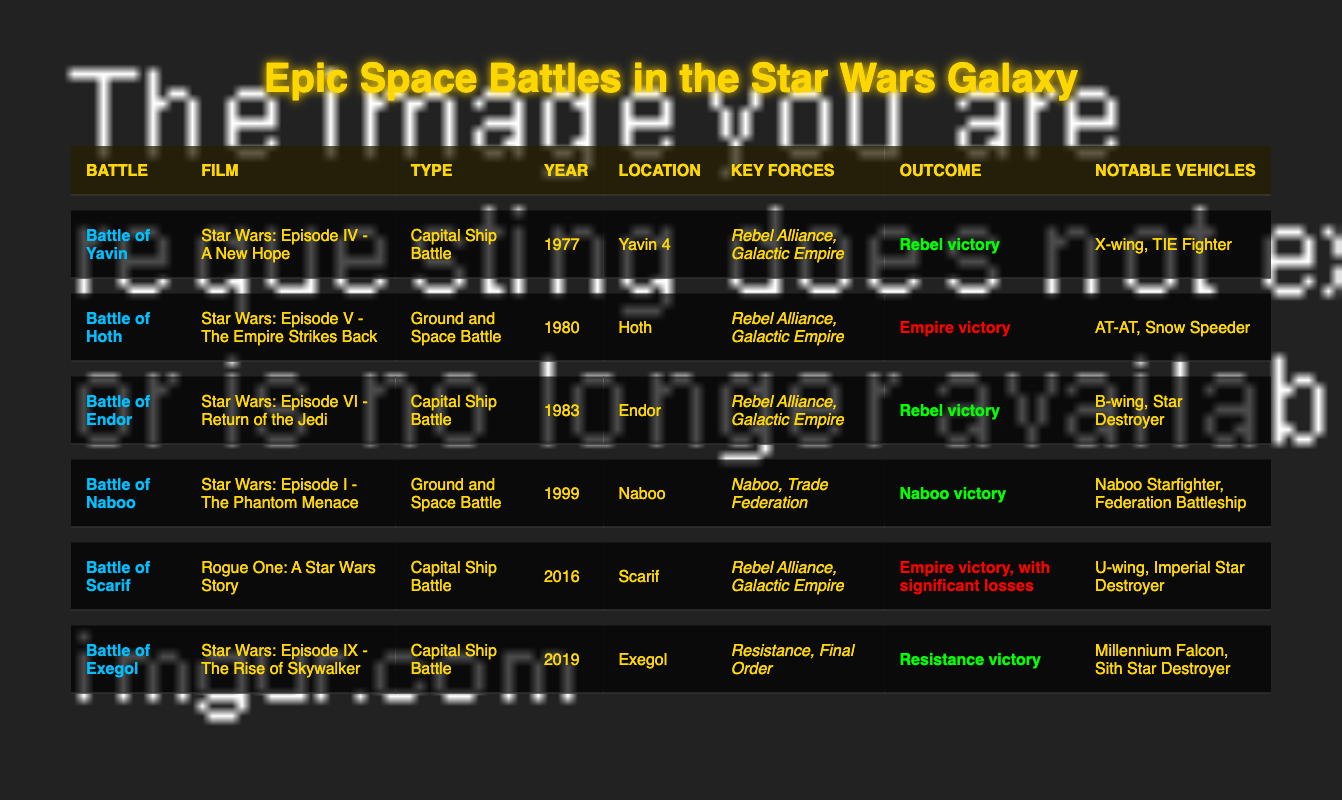What is the year of the Battle of Hoth? The Battle of Hoth is listed in the table and is noted to have occurred in the year 1980.
Answer: 1980 Which battle resulted in a Rebel victory? By reviewing the outcomes section of the table, the battles of Yavin, Endor, Naboo, and Exegol all resulted in a Rebel victory.
Answer: Battle of Yavin, Battle of Endor, Battle of Naboo, Battle of Exegol How many Capital Ship Battles are in the table? The table lists the battles of Yavin, Endor, Scarif, and Exegol as Capital Ship Battles. Counting these gives a total of four Capital Ship Battles.
Answer: 4 Did the Battle of Scarif result in an Empire victory? The outcome of the Battle of Scarif in the table indicates it was an Empire victory, albeit with significant losses.
Answer: Yes What is the most recent battle depicted in the table? The last battle listed is the Battle of Exegol, which occurred in the year 2019. Therefore, it is the most recent battle depicted.
Answer: Battle of Exegol What percentage of the battles resulted in a victory for the Rebel Alliance? There are 6 battles in total and 4 of them resulted in a victory for the Rebel Alliance. To find the percentage: (4/6) * 100 = 66.67%.
Answer: 66.67% Which battle featured the Millennium Falcon? The table indicates that the Millennium Falcon was notable in the Battle of Exegol. Therefore, the battle that featured the Millennium Falcon is Exegol.
Answer: Battle of Exegol Was the Battle of Naboo a Ground and Space Battle? The table states that the Battle of Naboo is classified as a Ground and Space Battle. Therefore, the statement is true.
Answer: Yes Which force was present in the most battles according to the table? Reviewing the key forces in each battle shows the Rebel Alliance appears in battles of Yavin, Hoth, Endor, and Scarif, totaling four battles compared to others.
Answer: Rebel Alliance What is the outcome of the Battle of Endor? The outcome section of the table specifies that the outcome of the Battle of Endor was a Rebel victory.
Answer: Rebel victory 